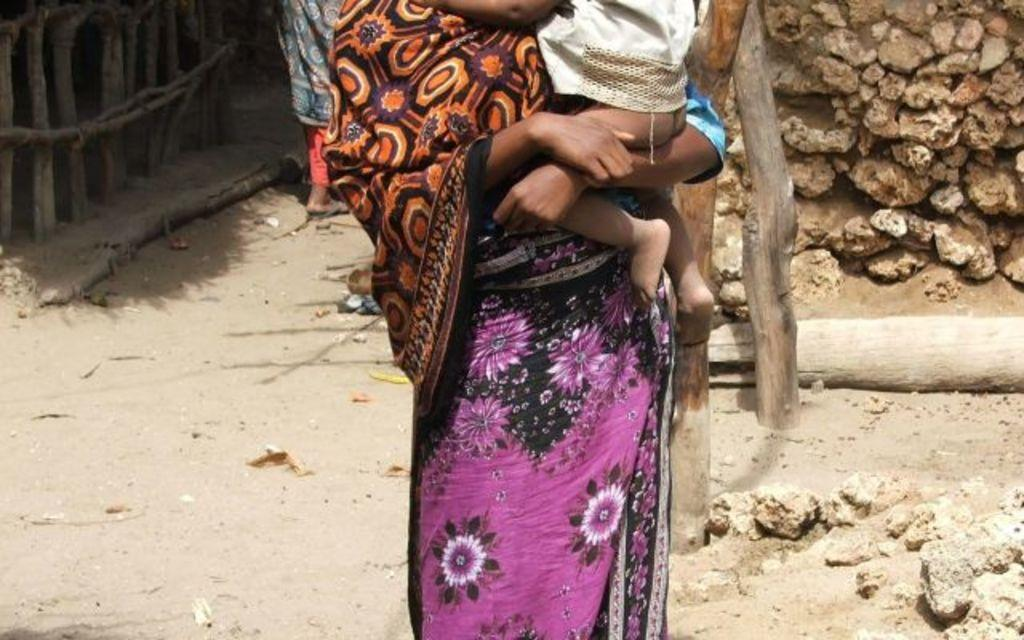What is the person in the image doing? The person is standing and carrying a kid in the image. What type of terrain is visible in the image? There are rocks in the image, suggesting a rocky or uneven terrain. What type of barrier is present in the image? There is a fence in the image. Can you describe the other person in the image? There is another person in the background of the image. What type of yoke is the person using to carry the kid in the image? There is no yoke present in the image; the person is simply carrying the kid. Where is the lunchroom located in the image? There is no mention of a lunchroom in the image; it features a person carrying a kid, rocks, a fence, and another person in the background. 